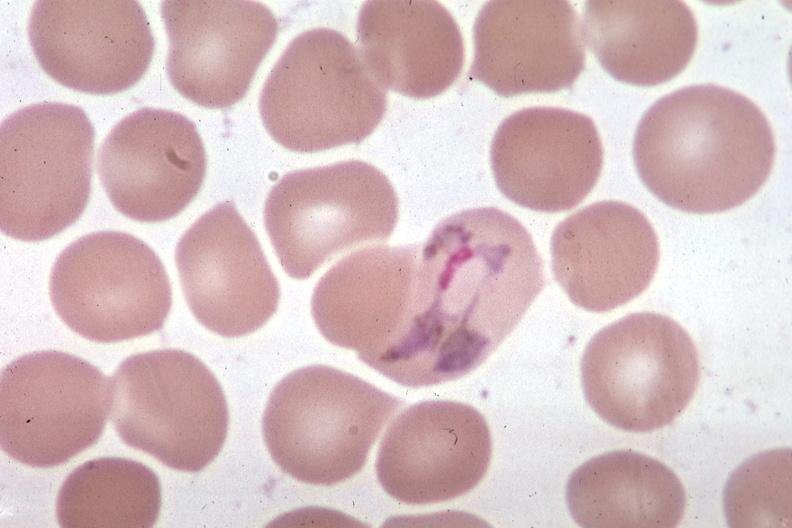s artery present?
Answer the question using a single word or phrase. No 